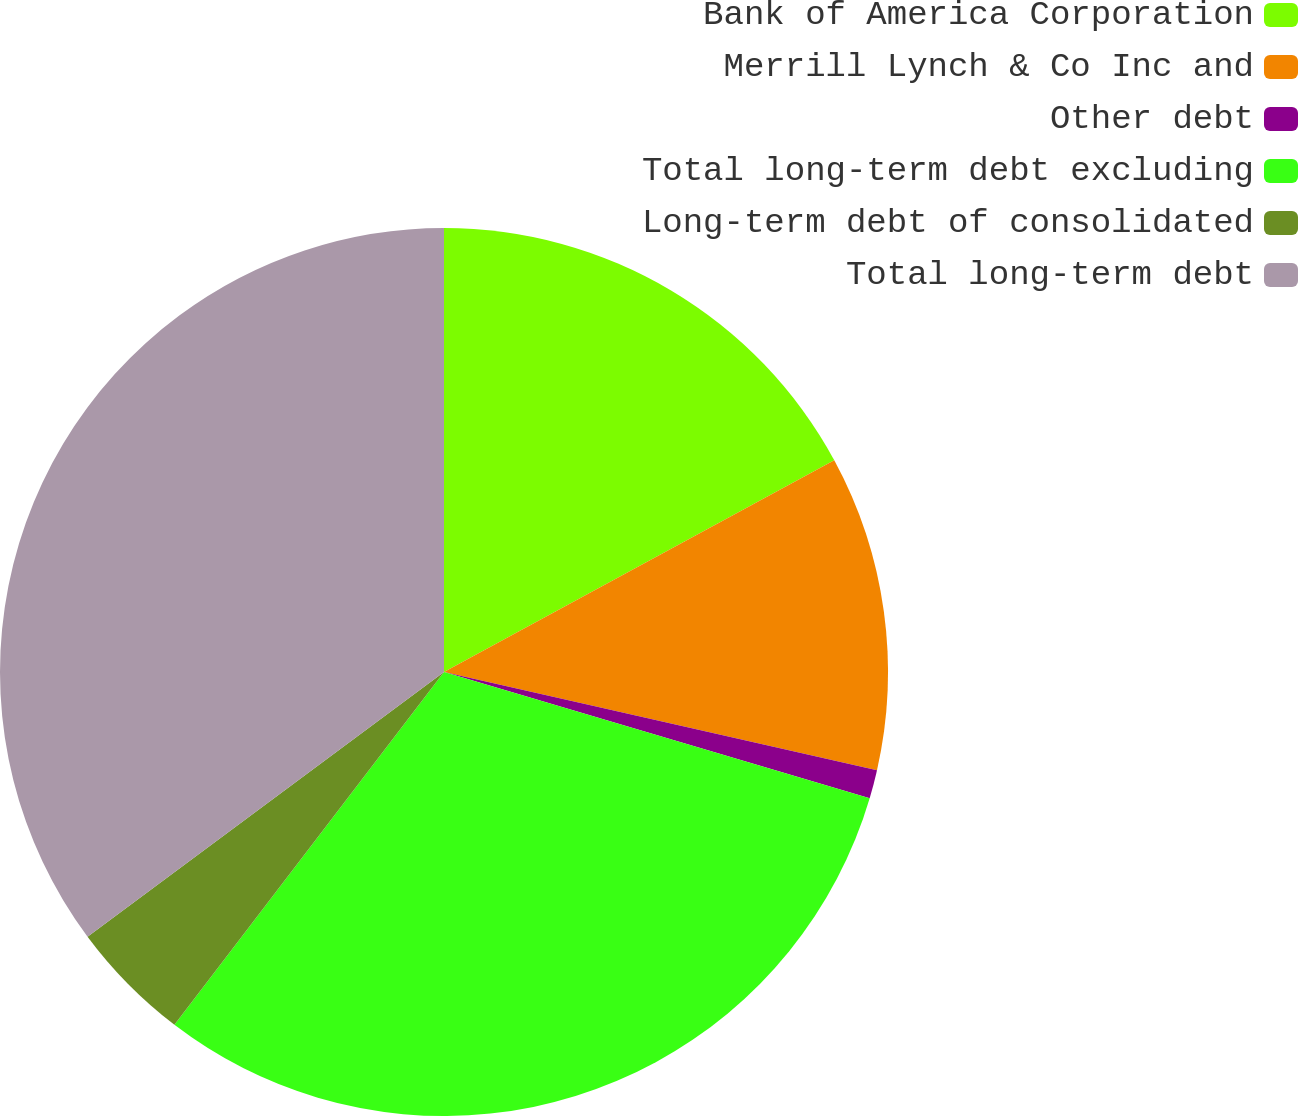Convert chart to OTSL. <chart><loc_0><loc_0><loc_500><loc_500><pie_chart><fcel>Bank of America Corporation<fcel>Merrill Lynch & Co Inc and<fcel>Other debt<fcel>Total long-term debt excluding<fcel>Long-term debt of consolidated<fcel>Total long-term debt<nl><fcel>17.09%<fcel>11.46%<fcel>1.04%<fcel>30.8%<fcel>4.45%<fcel>35.17%<nl></chart> 